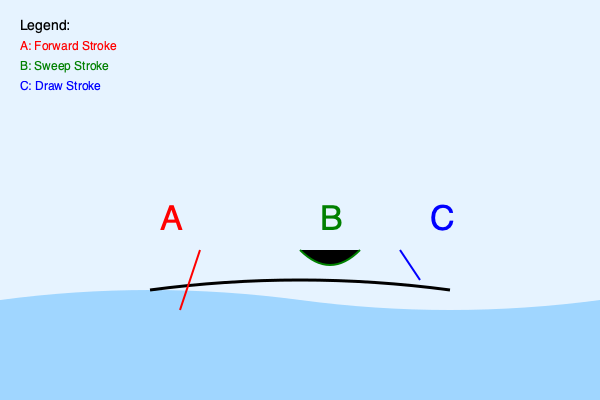In the diagram above, which paddle stroke technique would be most effective for turning the kayak quickly? To answer this question, let's examine the three paddle stroke techniques shown in the diagram:

1. Stroke A (Red): This is the Forward Stroke. It's used to propel the kayak forward in a straight line. While essential for general movement, it's not designed for turning.

2. Stroke B (Green): This is the Sweep Stroke. It's characterized by a wide, arcing motion that starts at the bow (front) of the kayak and ends at the stern (back). The sweep stroke is specifically designed to turn the kayak efficiently.

3. Stroke C (Blue): This is the Draw Stroke. It's used to move the kayak sideways, which can be useful for fine adjustments or approaching a dock, but it's not primarily used for turning.

Among these three options, the Sweep Stroke (B) is the most effective for turning the kayak quickly. Here's why:

1. It uses the full length of the kayak as leverage, creating a powerful turning force.
2. The wide, sweeping motion allows for a smooth, continuous turn.
3. It can be performed on either side of the kayak to turn in the desired direction.
4. The sweep stroke is specifically designed and commonly used for turning maneuvers in kayaking.

Therefore, based on the information provided in the diagram and the characteristics of each stroke, the Sweep Stroke (B) would be the most effective for turning the kayak quickly.
Answer: Sweep Stroke (B) 